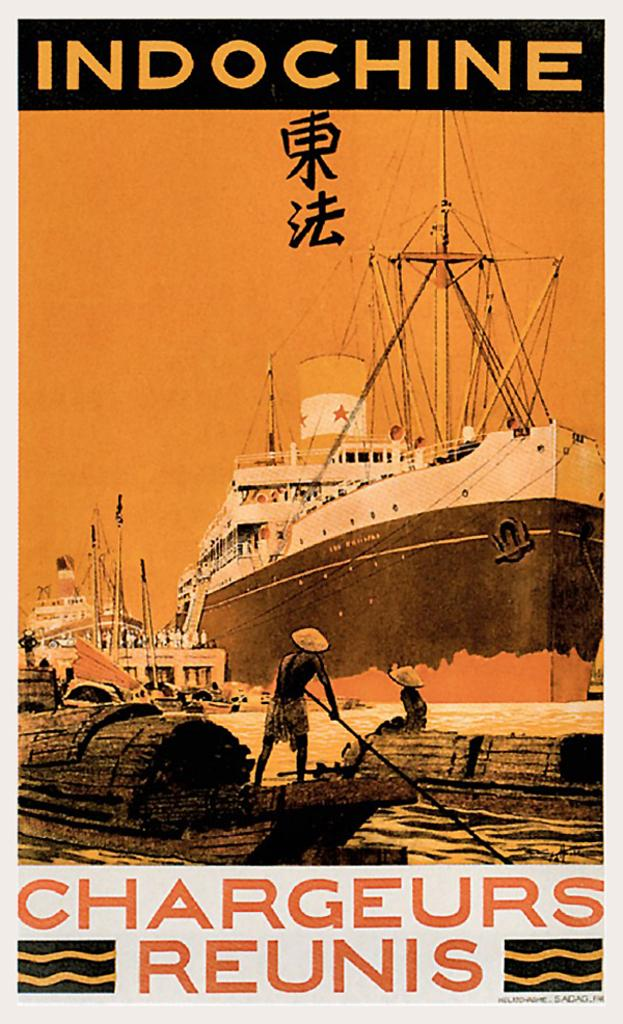What is the main subject of the poster in the image? The poster contains a ship and boats. Are there any people depicted in the poster? Yes, there are people (few persons) in the poster. What else can be found on the poster besides the ship and boats? There is text on the poster. What color is the spark on the poster? There is no spark present on the poster. How many hearts are visible on the poster? There are no hearts visible on the poster. 